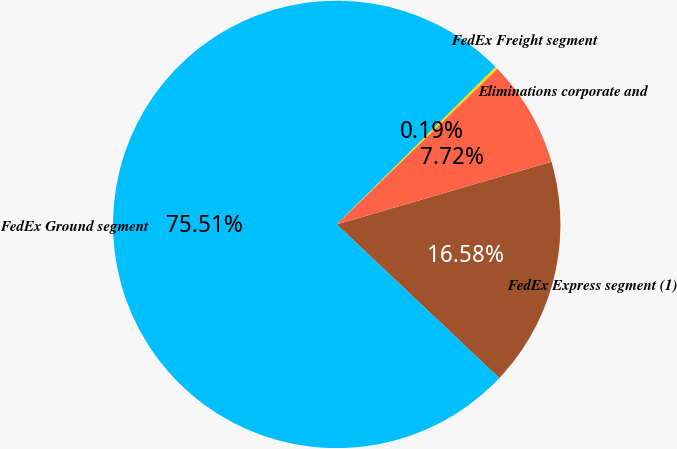Convert chart. <chart><loc_0><loc_0><loc_500><loc_500><pie_chart><fcel>FedEx Express segment (1)<fcel>FedEx Ground segment<fcel>FedEx Freight segment<fcel>Eliminations corporate and<nl><fcel>16.58%<fcel>75.51%<fcel>0.19%<fcel>7.72%<nl></chart> 